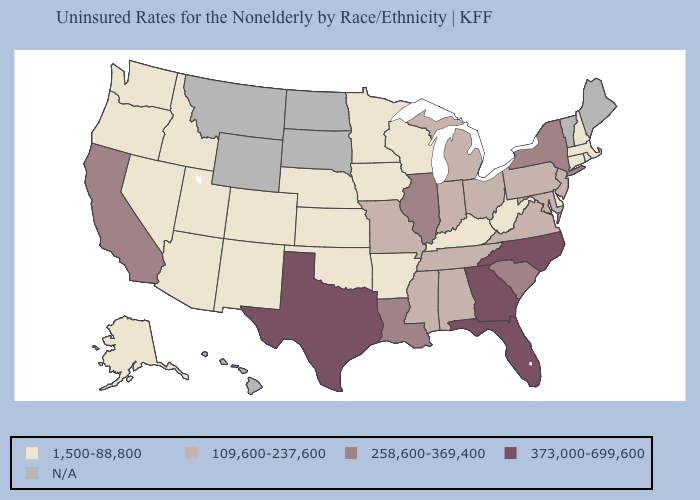What is the value of Indiana?
Be succinct. 109,600-237,600. What is the highest value in states that border South Dakota?
Give a very brief answer. 1,500-88,800. What is the value of New York?
Keep it brief. 258,600-369,400. What is the lowest value in the USA?
Be succinct. 1,500-88,800. Does Nevada have the highest value in the USA?
Keep it brief. No. Does Nevada have the lowest value in the USA?
Be succinct. Yes. What is the value of West Virginia?
Quick response, please. 1,500-88,800. What is the value of Nevada?
Keep it brief. 1,500-88,800. Name the states that have a value in the range 258,600-369,400?
Short answer required. California, Illinois, Louisiana, New York, South Carolina. Name the states that have a value in the range N/A?
Answer briefly. Hawaii, Maine, Montana, North Dakota, South Dakota, Vermont, Wyoming. What is the value of Missouri?
Write a very short answer. 109,600-237,600. What is the lowest value in states that border New Mexico?
Write a very short answer. 1,500-88,800. Name the states that have a value in the range 258,600-369,400?
Concise answer only. California, Illinois, Louisiana, New York, South Carolina. What is the value of New Hampshire?
Quick response, please. 1,500-88,800. What is the value of South Carolina?
Short answer required. 258,600-369,400. 